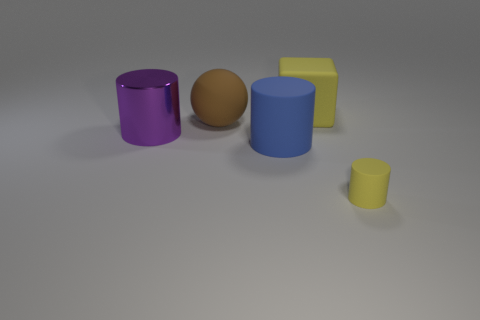Is there anything else that has the same size as the yellow cylinder?
Provide a succinct answer. No. Is the color of the small cylinder the same as the cube?
Your answer should be very brief. Yes. There is a large matte thing left of the blue matte object to the right of the purple metal object; how many objects are to the left of it?
Your answer should be compact. 1. The yellow cylinder is what size?
Keep it short and to the point. Small. What is the material of the purple object that is the same size as the brown ball?
Ensure brevity in your answer.  Metal. What number of yellow blocks are in front of the blue thing?
Give a very brief answer. 0. Is the large cylinder that is left of the big blue thing made of the same material as the cylinder in front of the large matte cylinder?
Provide a succinct answer. No. What shape is the yellow object that is in front of the matte cylinder that is on the left side of the yellow rubber object to the left of the tiny yellow matte cylinder?
Ensure brevity in your answer.  Cylinder. The tiny thing has what shape?
Keep it short and to the point. Cylinder. The blue matte object that is the same size as the yellow rubber block is what shape?
Provide a succinct answer. Cylinder. 